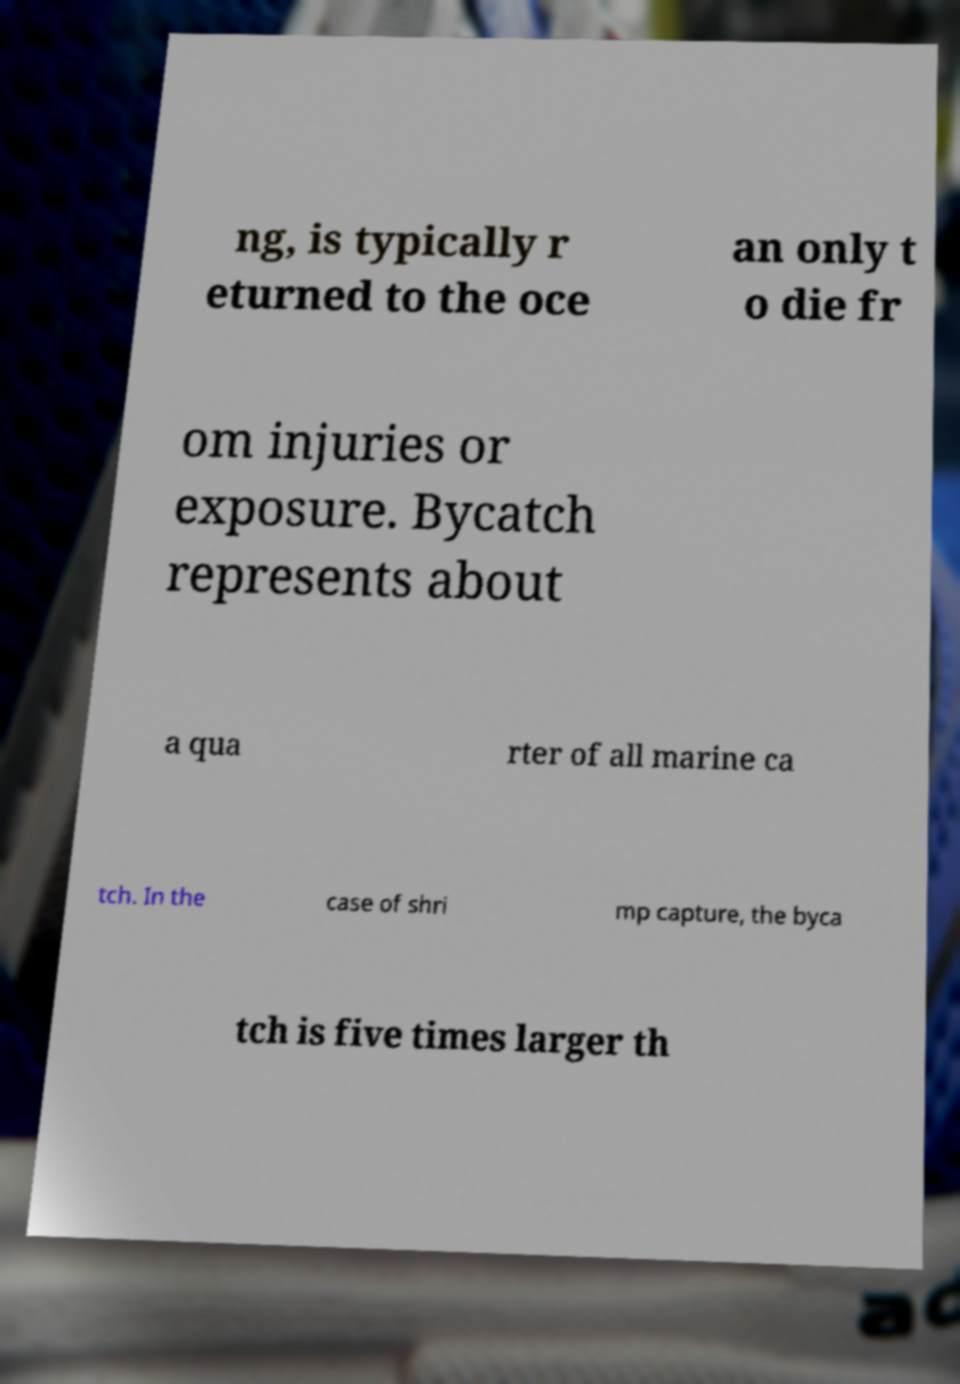I need the written content from this picture converted into text. Can you do that? ng, is typically r eturned to the oce an only t o die fr om injuries or exposure. Bycatch represents about a qua rter of all marine ca tch. In the case of shri mp capture, the byca tch is five times larger th 